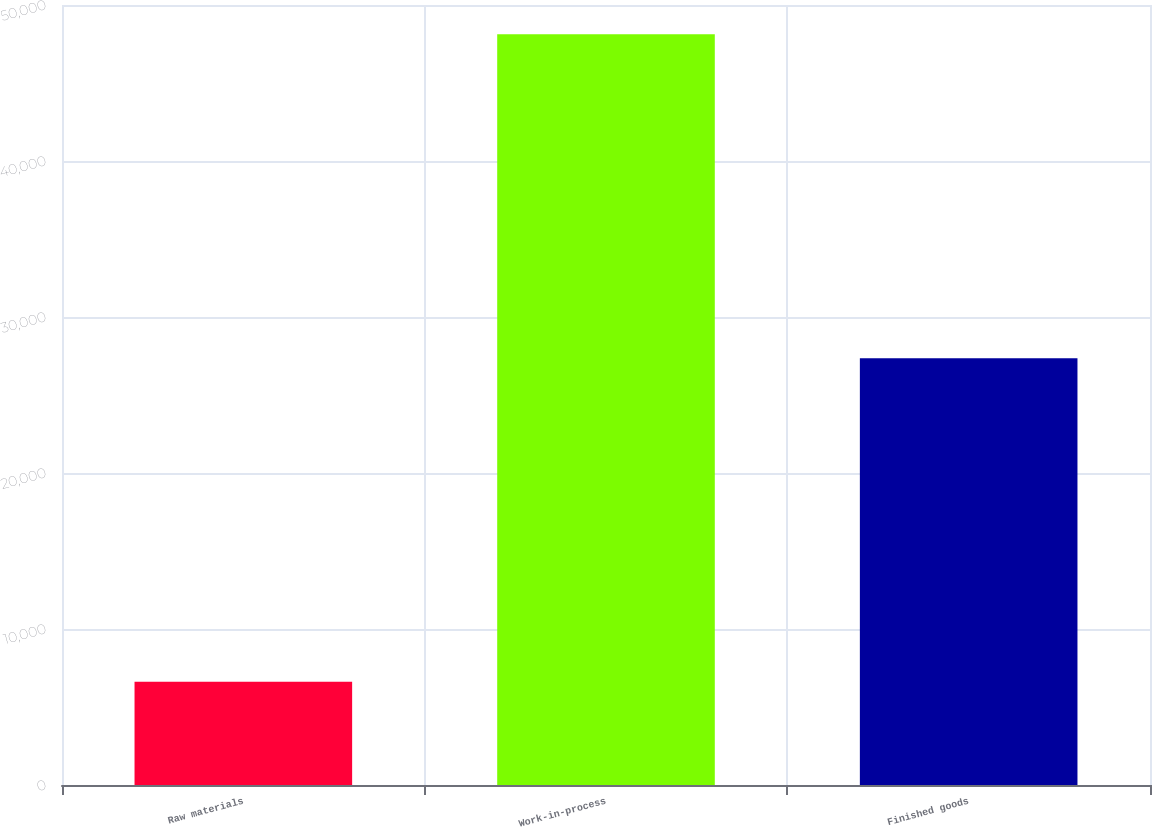Convert chart to OTSL. <chart><loc_0><loc_0><loc_500><loc_500><bar_chart><fcel>Raw materials<fcel>Work-in-process<fcel>Finished goods<nl><fcel>6624<fcel>48128<fcel>27357<nl></chart> 